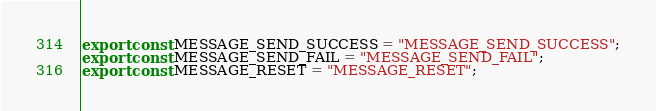<code> <loc_0><loc_0><loc_500><loc_500><_JavaScript_>export const MESSAGE_SEND_SUCCESS = "MESSAGE_SEND_SUCCESS";
export const MESSAGE_SEND_FAIL = "MESSAGE_SEND_FAIL";
export const MESSAGE_RESET = "MESSAGE_RESET";</code> 